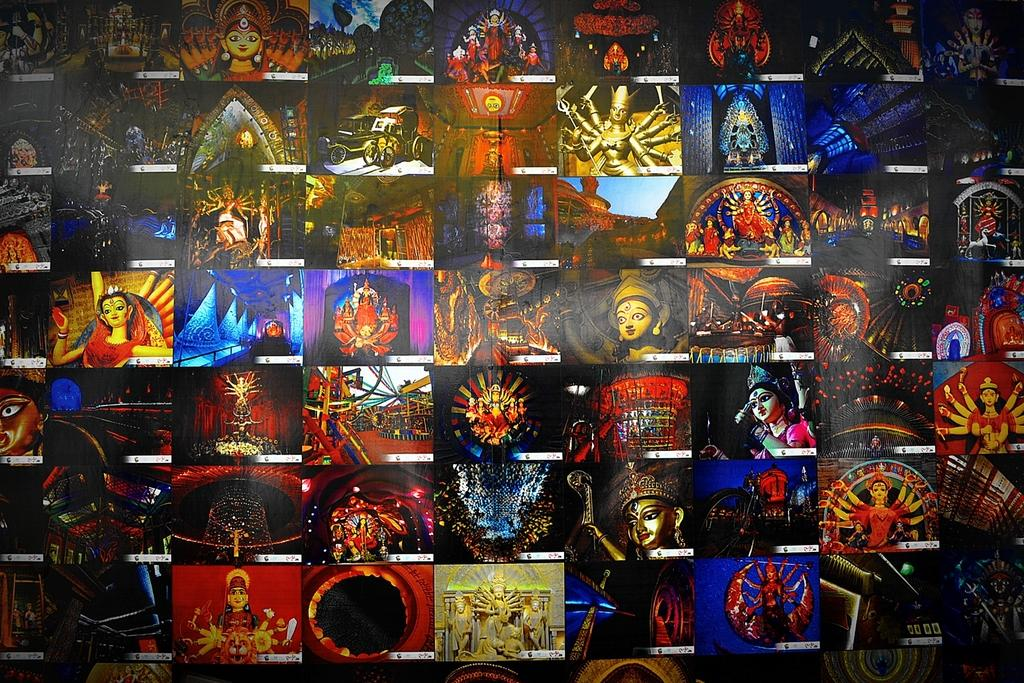What type of image is this? The image is edited and made as a college image. What can be seen in the pictures? There are idols and statues in the pictures. Where is the clock located in the image? There is no clock present in the image. What type of doll can be seen in the image? There is no doll present in the image. 